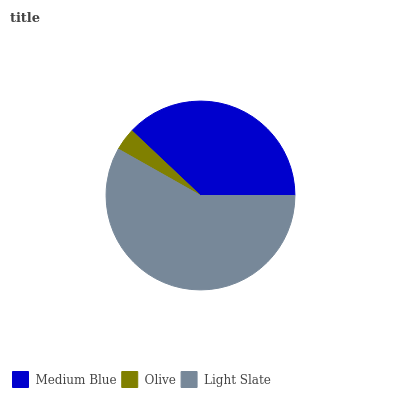Is Olive the minimum?
Answer yes or no. Yes. Is Light Slate the maximum?
Answer yes or no. Yes. Is Light Slate the minimum?
Answer yes or no. No. Is Olive the maximum?
Answer yes or no. No. Is Light Slate greater than Olive?
Answer yes or no. Yes. Is Olive less than Light Slate?
Answer yes or no. Yes. Is Olive greater than Light Slate?
Answer yes or no. No. Is Light Slate less than Olive?
Answer yes or no. No. Is Medium Blue the high median?
Answer yes or no. Yes. Is Medium Blue the low median?
Answer yes or no. Yes. Is Olive the high median?
Answer yes or no. No. Is Light Slate the low median?
Answer yes or no. No. 